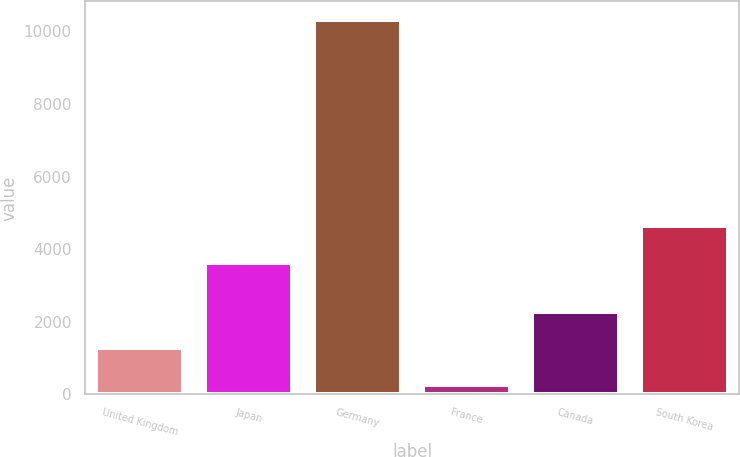Convert chart. <chart><loc_0><loc_0><loc_500><loc_500><bar_chart><fcel>United Kingdom<fcel>Japan<fcel>Germany<fcel>France<fcel>Canada<fcel>South Korea<nl><fcel>1268.8<fcel>3622<fcel>10312<fcel>264<fcel>2273.6<fcel>4626.8<nl></chart> 